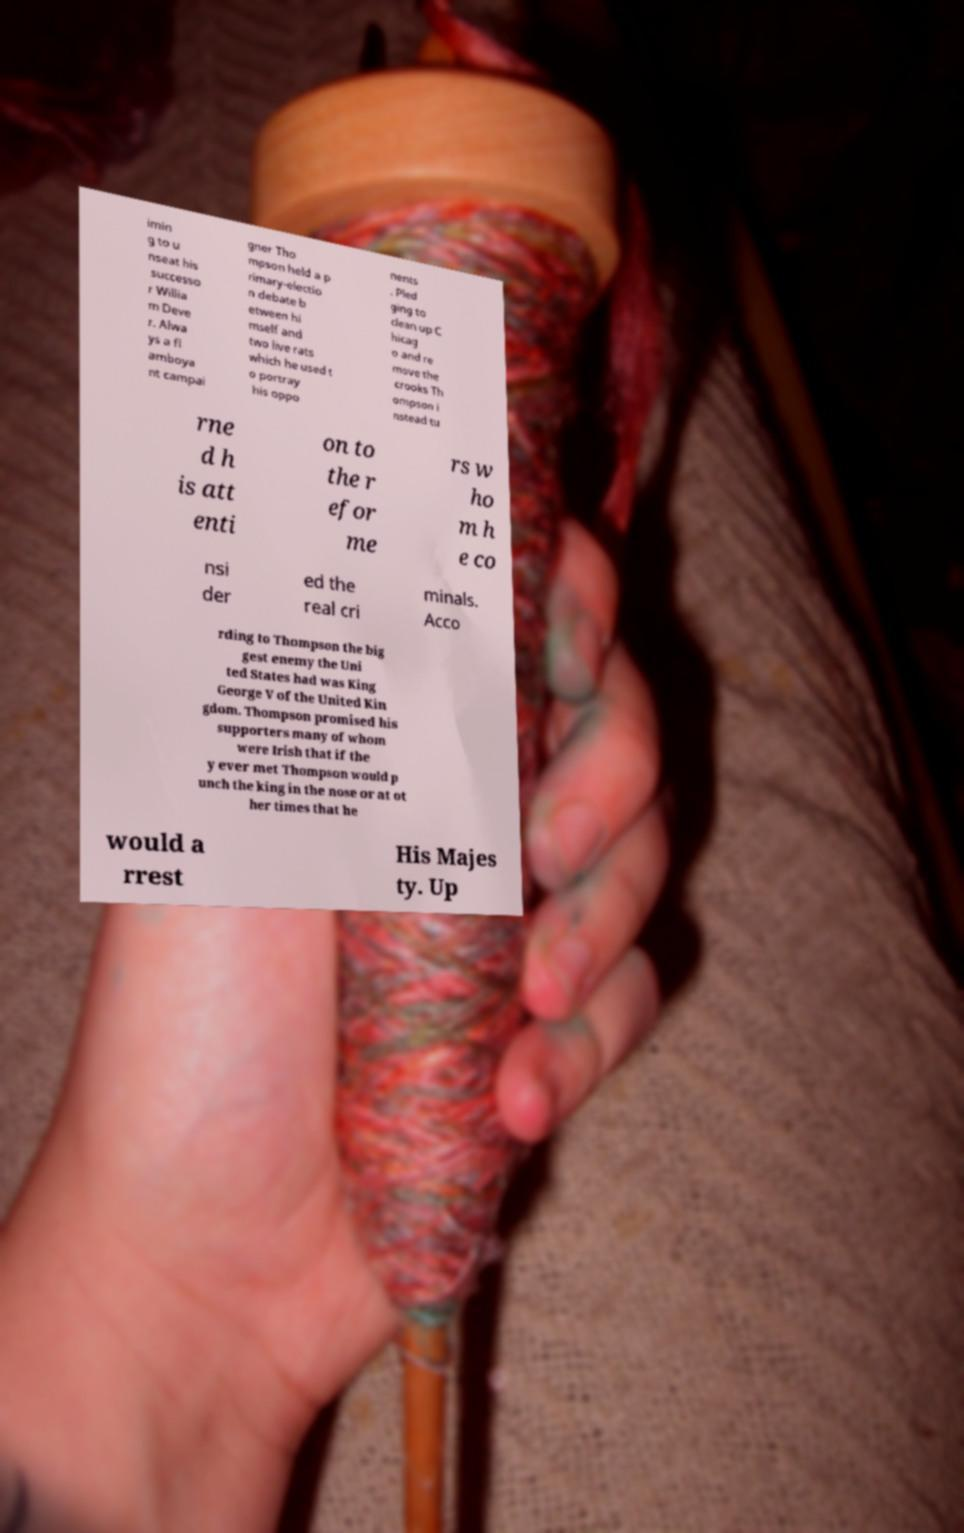Please read and relay the text visible in this image. What does it say? imin g to u nseat his successo r Willia m Deve r. Alwa ys a fl amboya nt campai gner Tho mpson held a p rimary-electio n debate b etween hi mself and two live rats which he used t o portray his oppo nents . Pled ging to clean up C hicag o and re move the crooks Th ompson i nstead tu rne d h is att enti on to the r efor me rs w ho m h e co nsi der ed the real cri minals. Acco rding to Thompson the big gest enemy the Uni ted States had was King George V of the United Kin gdom. Thompson promised his supporters many of whom were Irish that if the y ever met Thompson would p unch the king in the nose or at ot her times that he would a rrest His Majes ty. Up 